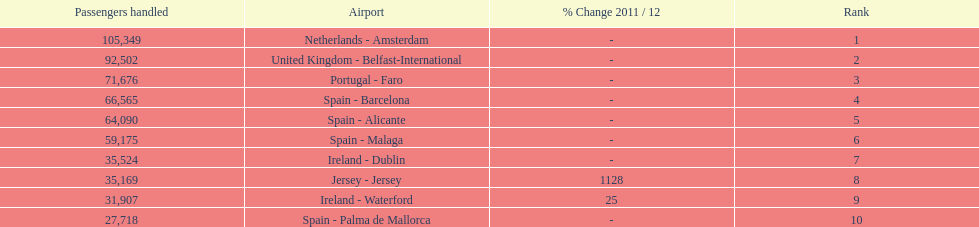Looking at the top 10 busiest routes to and from london southend airport what is the average number of passengers handled? 58,967.5. 